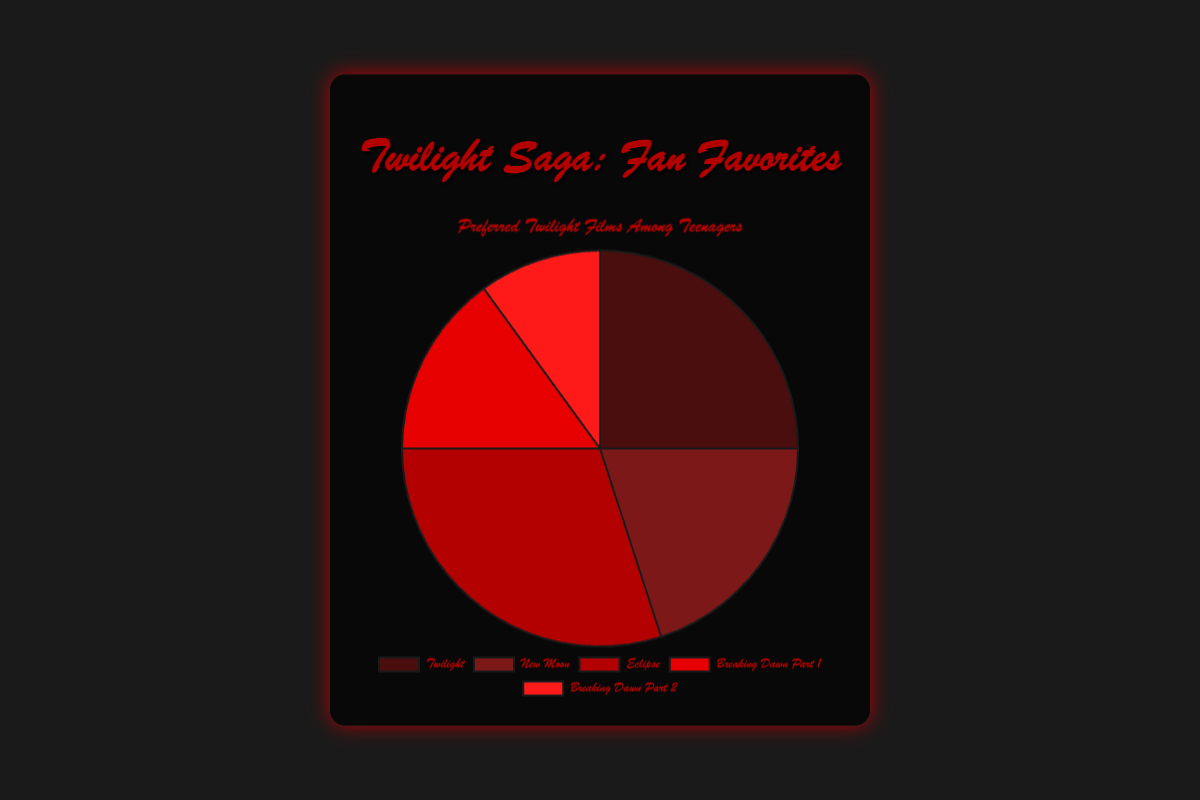what is the most preferred Twilight film among teenagers? The pie chart's largest segment represents the most preferred film. The "Eclipse" segment appears largest.
Answer: Eclipse which film is preferred less than "Twilight" but more than "Breaking Dawn Part 1"? From the chart, "Twilight" has 25 votes, "Breaking Dawn Part 1" has 15, and "New Moon" falls between those two with 20 votes.
Answer: New Moon how many more teenagers prefer "Eclipse" compared to "Breaking Dawn Part 2"? "Eclipse" has 30 votes, and "Breaking Dawn Part 2" has 10. The difference is 30 - 10.
Answer: 20 what percentage of teenagers prefer "Twilight" or "The Twilight Saga: New Moon"? Combine votes for "Twilight" (25) and "New Moon" (20), total is 25 + 20 = 45. The total votes are 100. The percentage is (45/100) * 100.
Answer: 45% which film is represented by the lightest red color? The segment with the lightest red color corresponds to "Breaking Dawn Part 2".
Answer: Breaking Dawn Part 2 compare the preference between "The Twilight Saga: Breaking Dawn Part 1" and "The Twilight Saga: Breaking Dawn Part 2"? "Breaking Dawn Part 1" has 15 votes, while "Breaking Dawn Part 2" has 10. "Breaking Dawn Part 1" is more preferred.
Answer: Breaking Dawn Part 1 combine the votes for "Twilight", "New Moon", and "Eclipse". how does this compare to the sum of the votes for both "Breaking Dawn" parts? Sum votes for "Twilight" (25), "New Moon" (20), and "Eclipse" (30) = 75. Sum votes for "Breaking Dawn Part 1" (15) and "Breaking Dawn Part 2" (10) = 25. 75 is greater than 25.
Answer: 75 > 25 